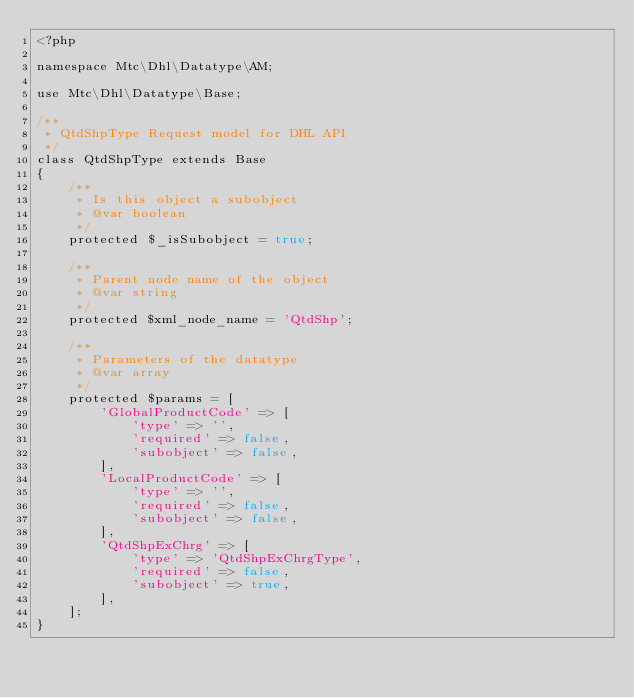Convert code to text. <code><loc_0><loc_0><loc_500><loc_500><_PHP_><?php

namespace Mtc\Dhl\Datatype\AM;

use Mtc\Dhl\Datatype\Base;

/**
 * QtdShpType Request model for DHL API
 */
class QtdShpType extends Base
{
    /**
     * Is this object a subobject
     * @var boolean
     */
    protected $_isSubobject = true;

    /**
     * Parent node name of the object
     * @var string
     */
    protected $xml_node_name = 'QtdShp';

    /**
     * Parameters of the datatype
     * @var array
     */
    protected $params = [
        'GlobalProductCode' => [
            'type' => '',
            'required' => false,
            'subobject' => false,
        ],
        'LocalProductCode' => [
            'type' => '',
            'required' => false,
            'subobject' => false,
        ],
        'QtdShpExChrg' => [
            'type' => 'QtdShpExChrgType',
            'required' => false,
            'subobject' => true,
        ],
    ];
}
</code> 